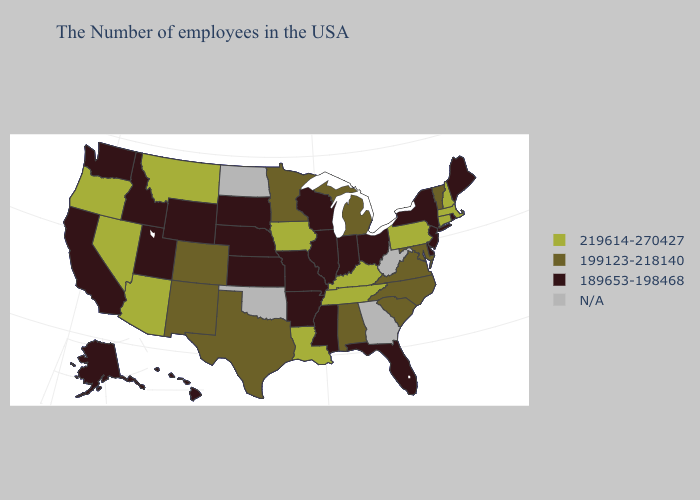What is the value of Nebraska?
Short answer required. 189653-198468. What is the value of Minnesota?
Be succinct. 199123-218140. Name the states that have a value in the range N/A?
Give a very brief answer. West Virginia, Georgia, Oklahoma, North Dakota. Does Ohio have the lowest value in the USA?
Concise answer only. Yes. What is the value of West Virginia?
Answer briefly. N/A. How many symbols are there in the legend?
Short answer required. 4. Name the states that have a value in the range 219614-270427?
Quick response, please. Massachusetts, New Hampshire, Connecticut, Pennsylvania, Kentucky, Tennessee, Louisiana, Iowa, Montana, Arizona, Nevada, Oregon. What is the highest value in the USA?
Concise answer only. 219614-270427. What is the lowest value in the South?
Answer briefly. 189653-198468. What is the highest value in the West ?
Concise answer only. 219614-270427. Name the states that have a value in the range N/A?
Write a very short answer. West Virginia, Georgia, Oklahoma, North Dakota. Which states have the lowest value in the USA?
Answer briefly. Maine, Rhode Island, New York, New Jersey, Delaware, Ohio, Florida, Indiana, Wisconsin, Illinois, Mississippi, Missouri, Arkansas, Kansas, Nebraska, South Dakota, Wyoming, Utah, Idaho, California, Washington, Alaska, Hawaii. Which states hav the highest value in the Northeast?
Concise answer only. Massachusetts, New Hampshire, Connecticut, Pennsylvania. Does Connecticut have the highest value in the USA?
Write a very short answer. Yes. 